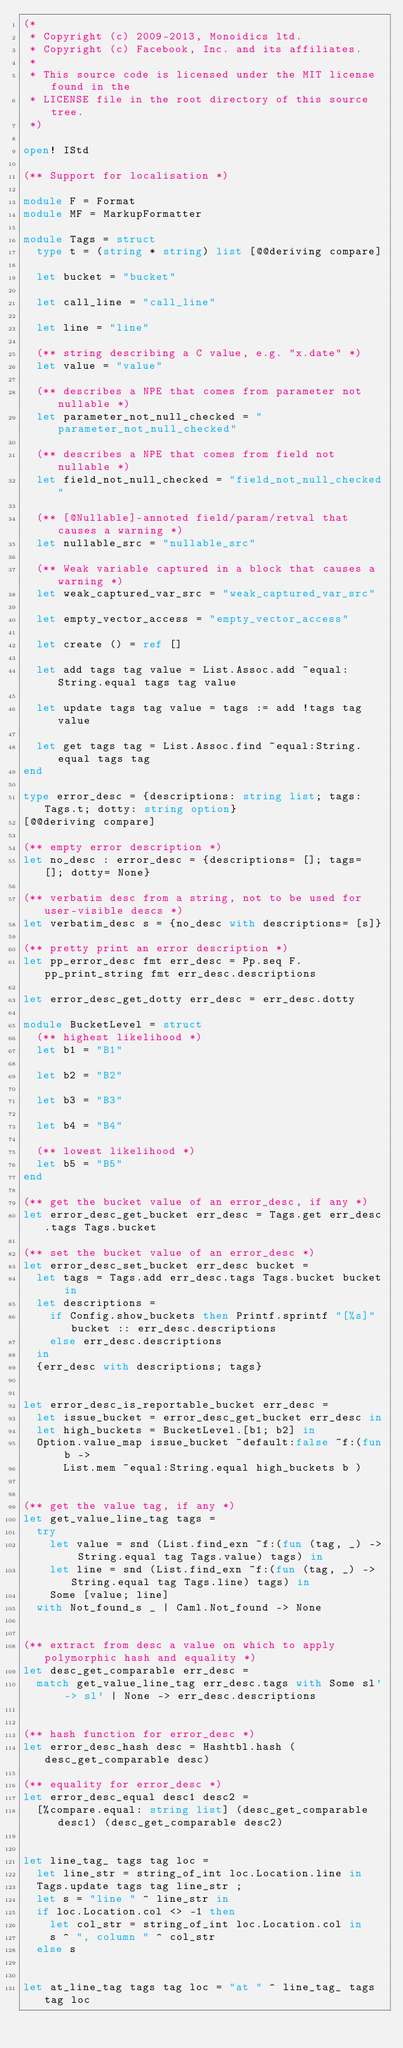Convert code to text. <code><loc_0><loc_0><loc_500><loc_500><_OCaml_>(*
 * Copyright (c) 2009-2013, Monoidics ltd.
 * Copyright (c) Facebook, Inc. and its affiliates.
 *
 * This source code is licensed under the MIT license found in the
 * LICENSE file in the root directory of this source tree.
 *)

open! IStd

(** Support for localisation *)

module F = Format
module MF = MarkupFormatter

module Tags = struct
  type t = (string * string) list [@@deriving compare]

  let bucket = "bucket"

  let call_line = "call_line"

  let line = "line"

  (** string describing a C value, e.g. "x.date" *)
  let value = "value"

  (** describes a NPE that comes from parameter not nullable *)
  let parameter_not_null_checked = "parameter_not_null_checked"

  (** describes a NPE that comes from field not nullable *)
  let field_not_null_checked = "field_not_null_checked"

  (** [@Nullable]-annoted field/param/retval that causes a warning *)
  let nullable_src = "nullable_src"

  (** Weak variable captured in a block that causes a warning *)
  let weak_captured_var_src = "weak_captured_var_src"

  let empty_vector_access = "empty_vector_access"

  let create () = ref []

  let add tags tag value = List.Assoc.add ~equal:String.equal tags tag value

  let update tags tag value = tags := add !tags tag value

  let get tags tag = List.Assoc.find ~equal:String.equal tags tag
end

type error_desc = {descriptions: string list; tags: Tags.t; dotty: string option}
[@@deriving compare]

(** empty error description *)
let no_desc : error_desc = {descriptions= []; tags= []; dotty= None}

(** verbatim desc from a string, not to be used for user-visible descs *)
let verbatim_desc s = {no_desc with descriptions= [s]}

(** pretty print an error description *)
let pp_error_desc fmt err_desc = Pp.seq F.pp_print_string fmt err_desc.descriptions

let error_desc_get_dotty err_desc = err_desc.dotty

module BucketLevel = struct
  (** highest likelihood *)
  let b1 = "B1"

  let b2 = "B2"

  let b3 = "B3"

  let b4 = "B4"

  (** lowest likelihood *)
  let b5 = "B5"
end

(** get the bucket value of an error_desc, if any *)
let error_desc_get_bucket err_desc = Tags.get err_desc.tags Tags.bucket

(** set the bucket value of an error_desc *)
let error_desc_set_bucket err_desc bucket =
  let tags = Tags.add err_desc.tags Tags.bucket bucket in
  let descriptions =
    if Config.show_buckets then Printf.sprintf "[%s]" bucket :: err_desc.descriptions
    else err_desc.descriptions
  in
  {err_desc with descriptions; tags}


let error_desc_is_reportable_bucket err_desc =
  let issue_bucket = error_desc_get_bucket err_desc in
  let high_buckets = BucketLevel.[b1; b2] in
  Option.value_map issue_bucket ~default:false ~f:(fun b ->
      List.mem ~equal:String.equal high_buckets b )


(** get the value tag, if any *)
let get_value_line_tag tags =
  try
    let value = snd (List.find_exn ~f:(fun (tag, _) -> String.equal tag Tags.value) tags) in
    let line = snd (List.find_exn ~f:(fun (tag, _) -> String.equal tag Tags.line) tags) in
    Some [value; line]
  with Not_found_s _ | Caml.Not_found -> None


(** extract from desc a value on which to apply polymorphic hash and equality *)
let desc_get_comparable err_desc =
  match get_value_line_tag err_desc.tags with Some sl' -> sl' | None -> err_desc.descriptions


(** hash function for error_desc *)
let error_desc_hash desc = Hashtbl.hash (desc_get_comparable desc)

(** equality for error_desc *)
let error_desc_equal desc1 desc2 =
  [%compare.equal: string list] (desc_get_comparable desc1) (desc_get_comparable desc2)


let line_tag_ tags tag loc =
  let line_str = string_of_int loc.Location.line in
  Tags.update tags tag line_str ;
  let s = "line " ^ line_str in
  if loc.Location.col <> -1 then
    let col_str = string_of_int loc.Location.col in
    s ^ ", column " ^ col_str
  else s


let at_line_tag tags tag loc = "at " ^ line_tag_ tags tag loc
</code> 